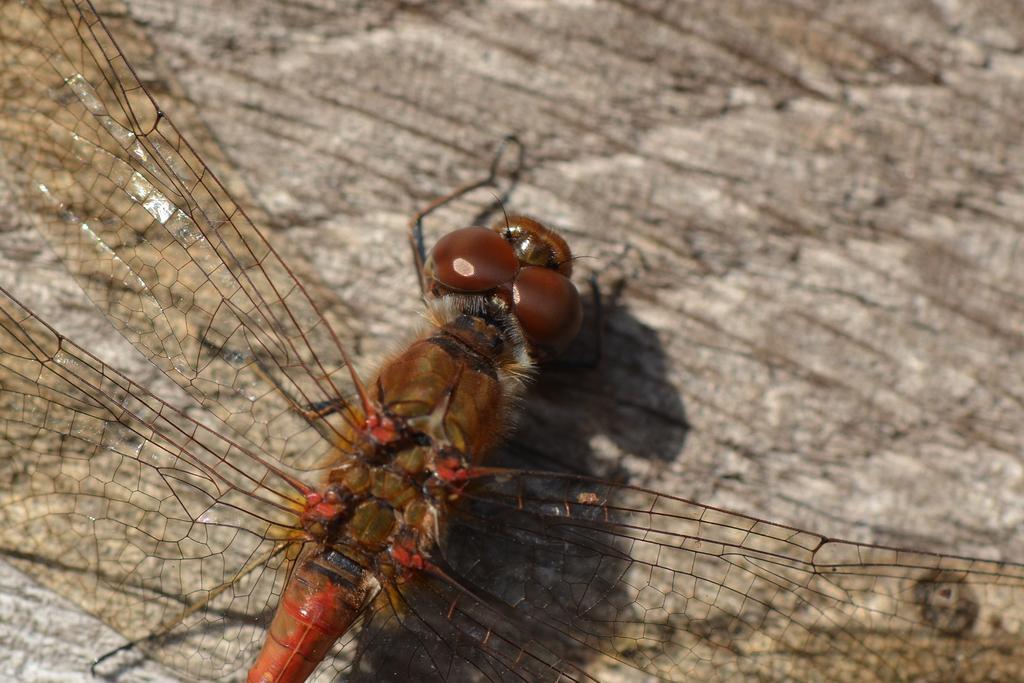Could you give a brief overview of what you see in this image? In this image we can see a fly on brown surface. 